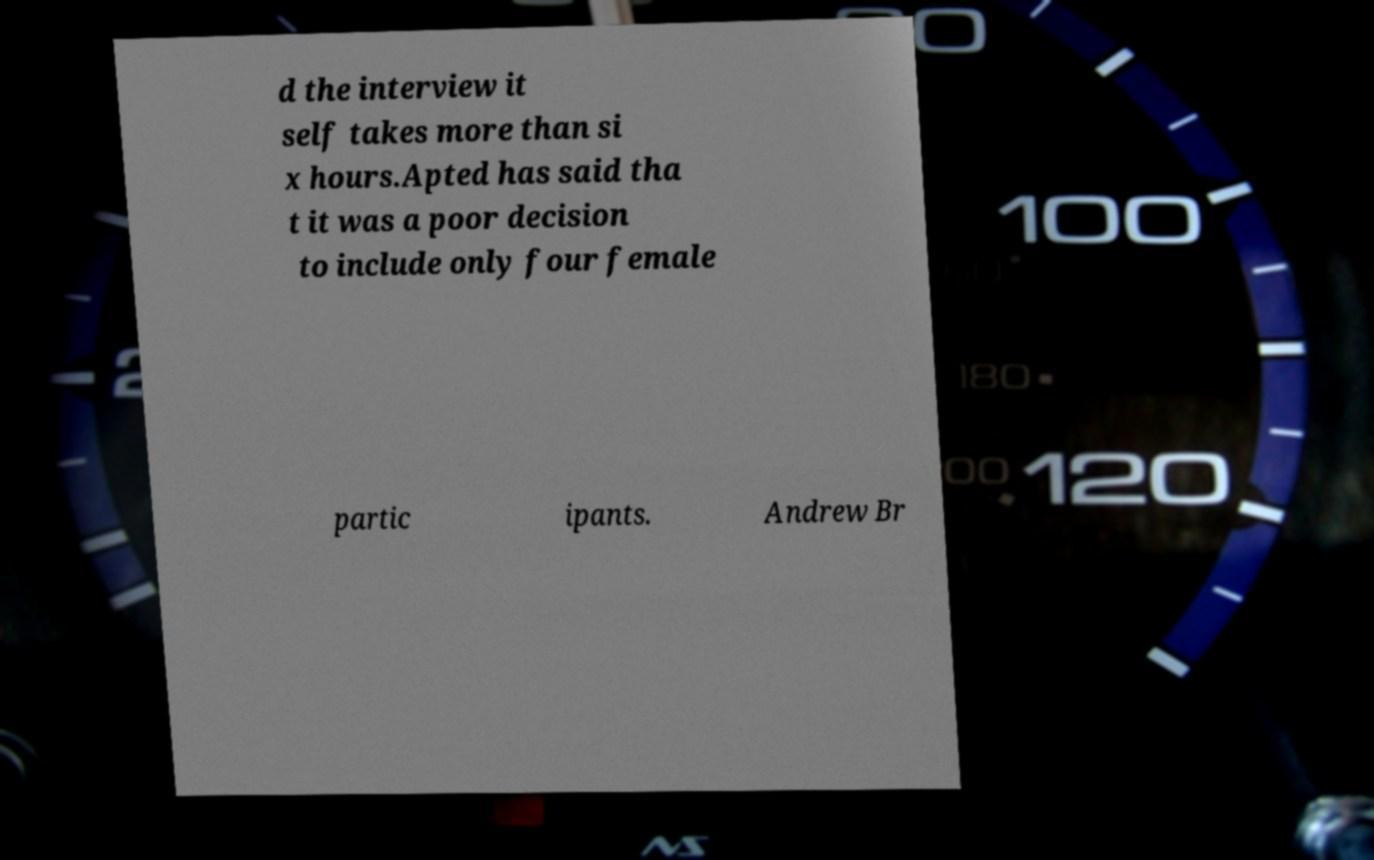Can you read and provide the text displayed in the image?This photo seems to have some interesting text. Can you extract and type it out for me? d the interview it self takes more than si x hours.Apted has said tha t it was a poor decision to include only four female partic ipants. Andrew Br 